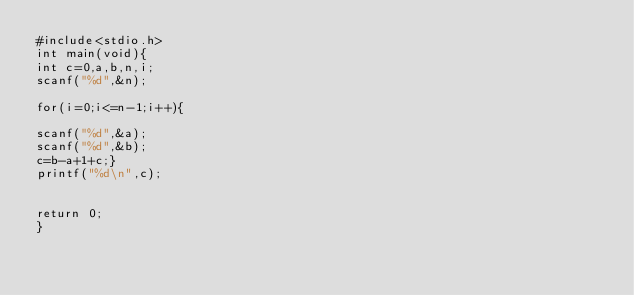<code> <loc_0><loc_0><loc_500><loc_500><_C_>#include<stdio.h>
int main(void){
int c=0,a,b,n,i;
scanf("%d",&n);

for(i=0;i<=n-1;i++){

scanf("%d",&a);
scanf("%d",&b);
c=b-a+1+c;}
printf("%d\n",c);


return 0;
}</code> 